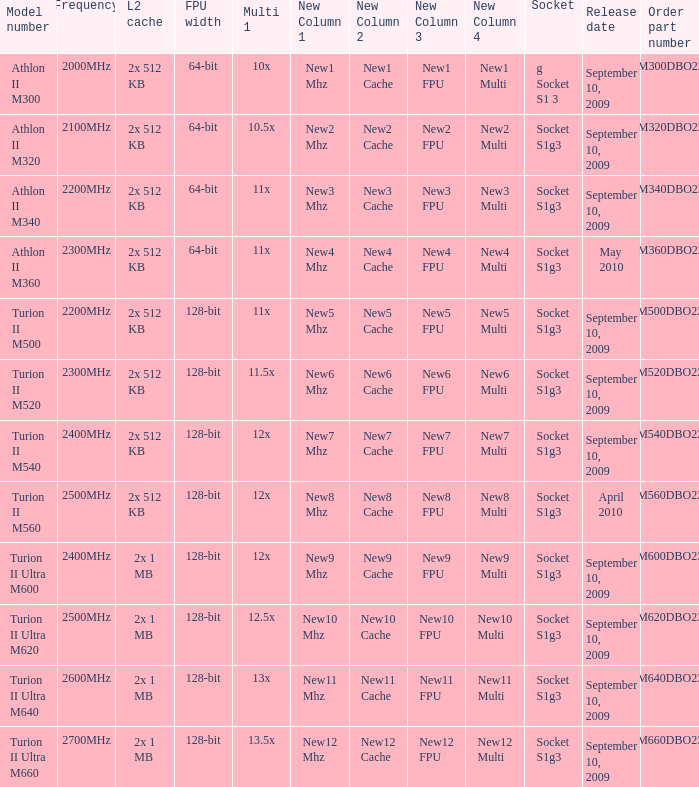What is the L2 cache with a release date on September 10, 2009, a 128-bit FPU width, and a 12x multi 1? 2x 512 KB, 2x 1 MB. 